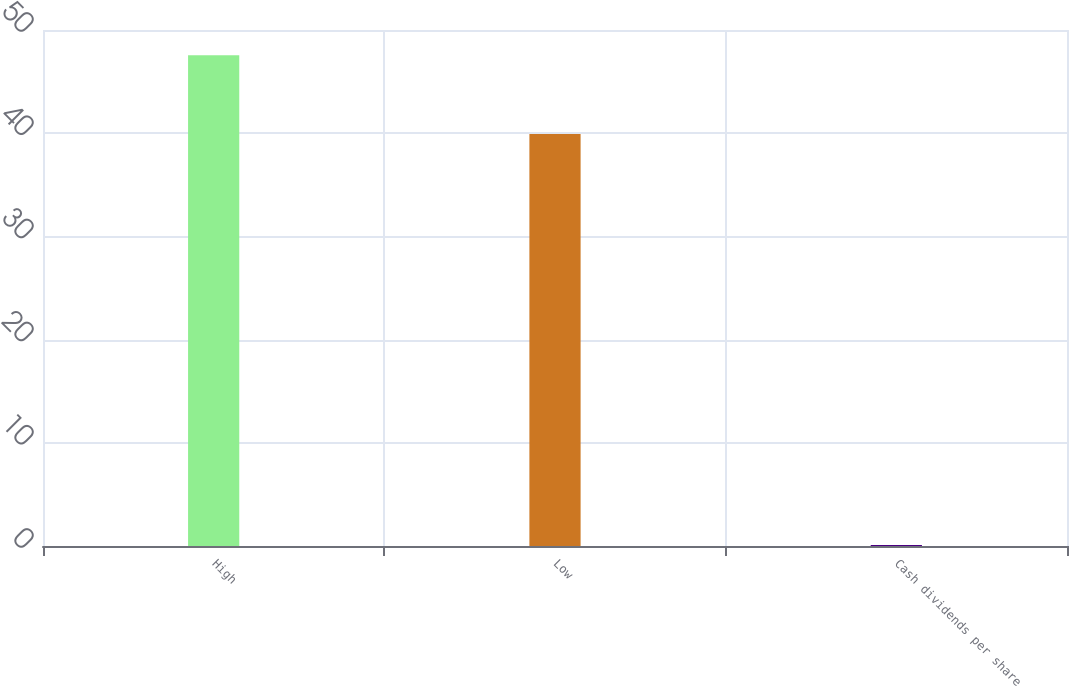<chart> <loc_0><loc_0><loc_500><loc_500><bar_chart><fcel>High<fcel>Low<fcel>Cash dividends per share<nl><fcel>47.56<fcel>39.92<fcel>0.1<nl></chart> 